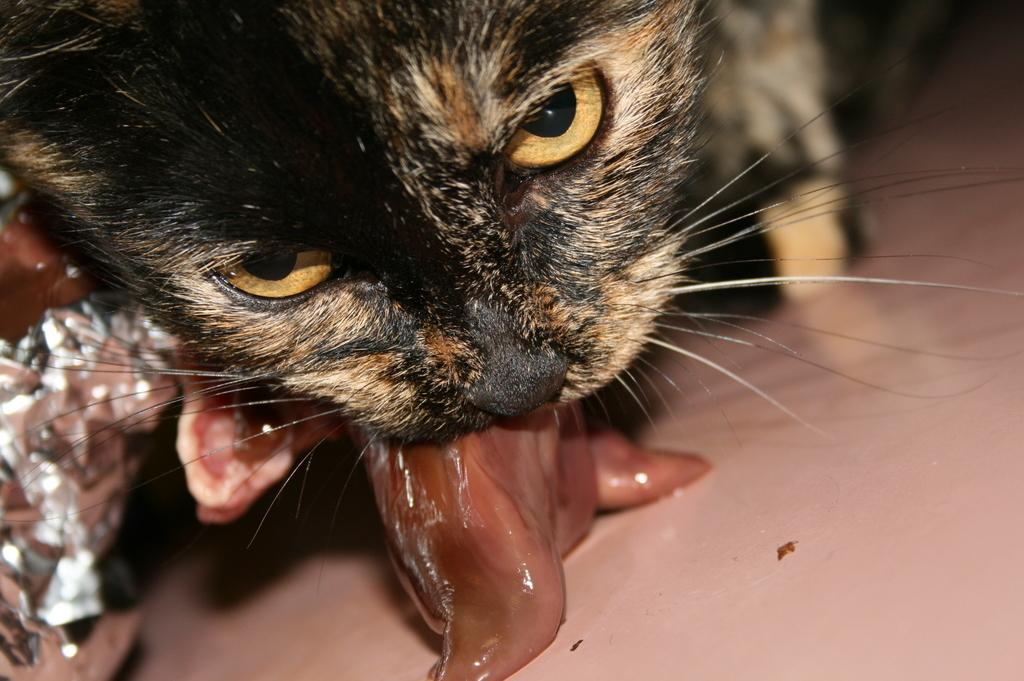What animal is present in the image? There is a cat in the image. What is the cat doing in the image? The cat is holding meat in its mouth. Can you describe any other objects in the image? There is foil paper in the bottom left corner of the image. Are there any women involved in the crime depicted in the image? There is no crime or women present in the image. 